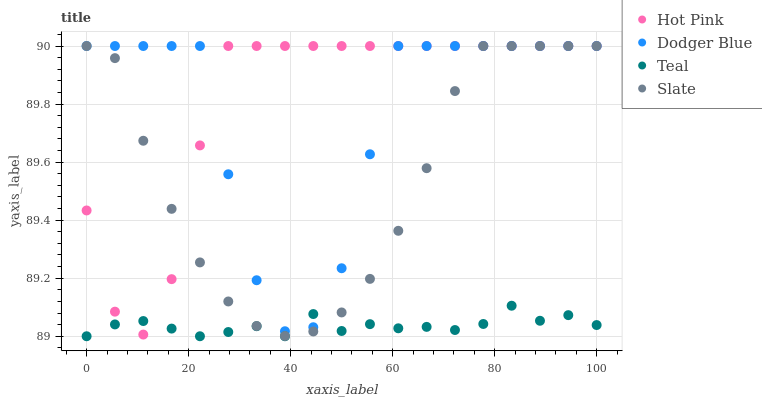Does Teal have the minimum area under the curve?
Answer yes or no. Yes. Does Hot Pink have the maximum area under the curve?
Answer yes or no. Yes. Does Dodger Blue have the minimum area under the curve?
Answer yes or no. No. Does Dodger Blue have the maximum area under the curve?
Answer yes or no. No. Is Teal the smoothest?
Answer yes or no. Yes. Is Dodger Blue the roughest?
Answer yes or no. Yes. Is Hot Pink the smoothest?
Answer yes or no. No. Is Hot Pink the roughest?
Answer yes or no. No. Does Teal have the lowest value?
Answer yes or no. Yes. Does Hot Pink have the lowest value?
Answer yes or no. No. Does Dodger Blue have the highest value?
Answer yes or no. Yes. Does Teal have the highest value?
Answer yes or no. No. Does Slate intersect Teal?
Answer yes or no. Yes. Is Slate less than Teal?
Answer yes or no. No. Is Slate greater than Teal?
Answer yes or no. No. 